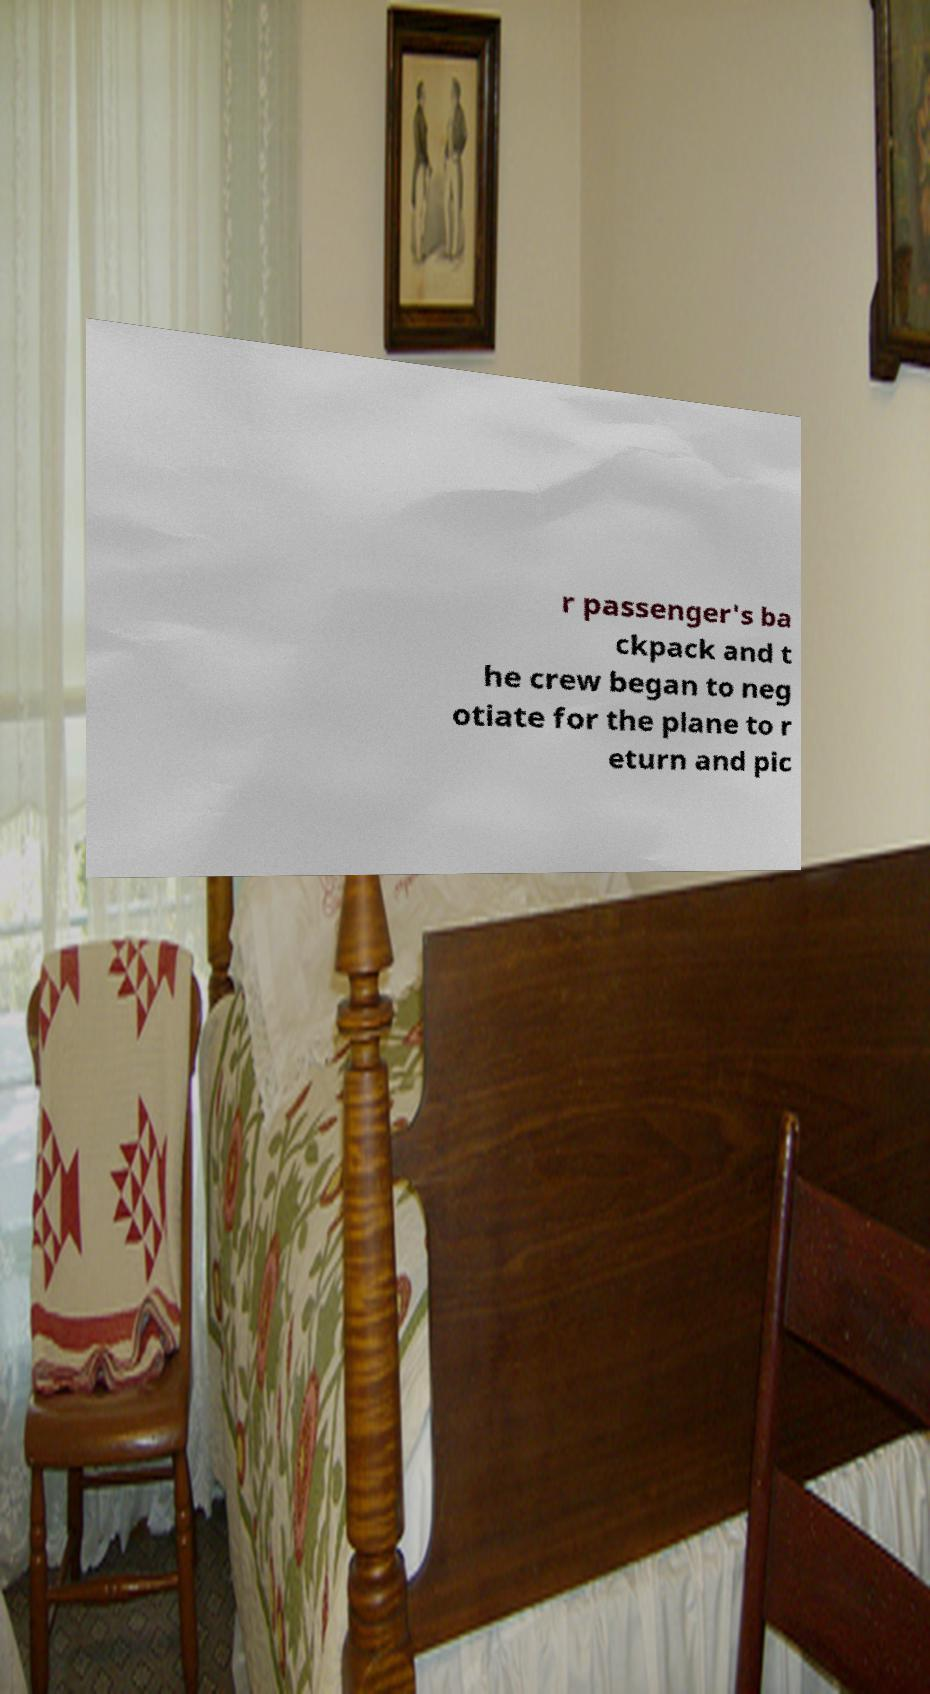Can you read and provide the text displayed in the image?This photo seems to have some interesting text. Can you extract and type it out for me? r passenger's ba ckpack and t he crew began to neg otiate for the plane to r eturn and pic 